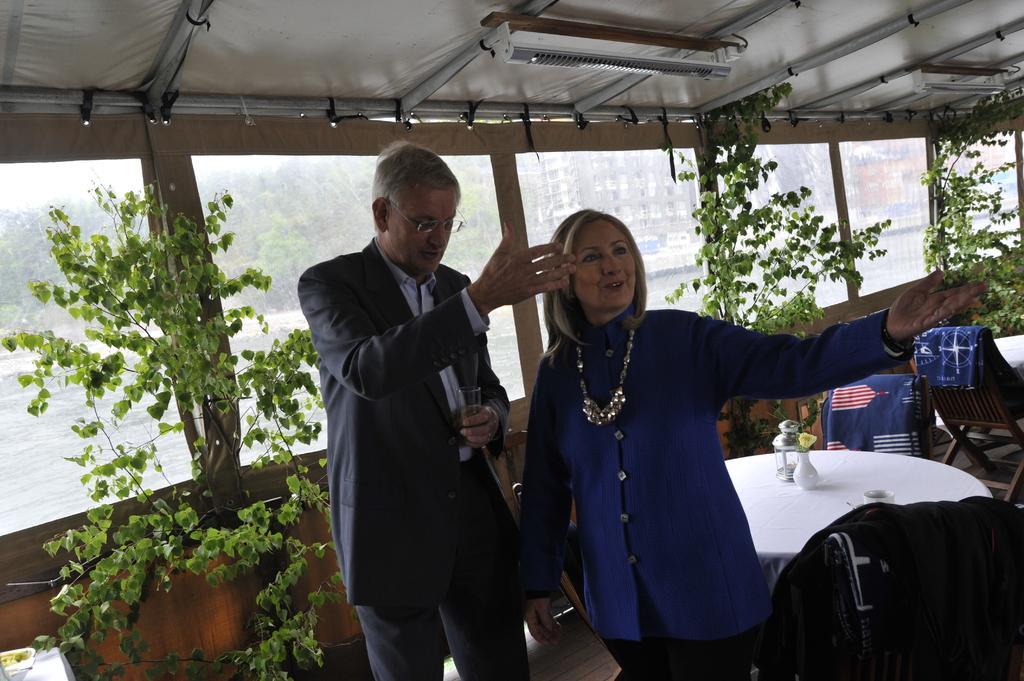Can you describe this image briefly? A man and woman is standing on the floor. Behind them there are tables,chairs,plants and a cloth. This is a tent actually and a light is fixed to the pole. Through this transparent screen we can see trees and buildings. 